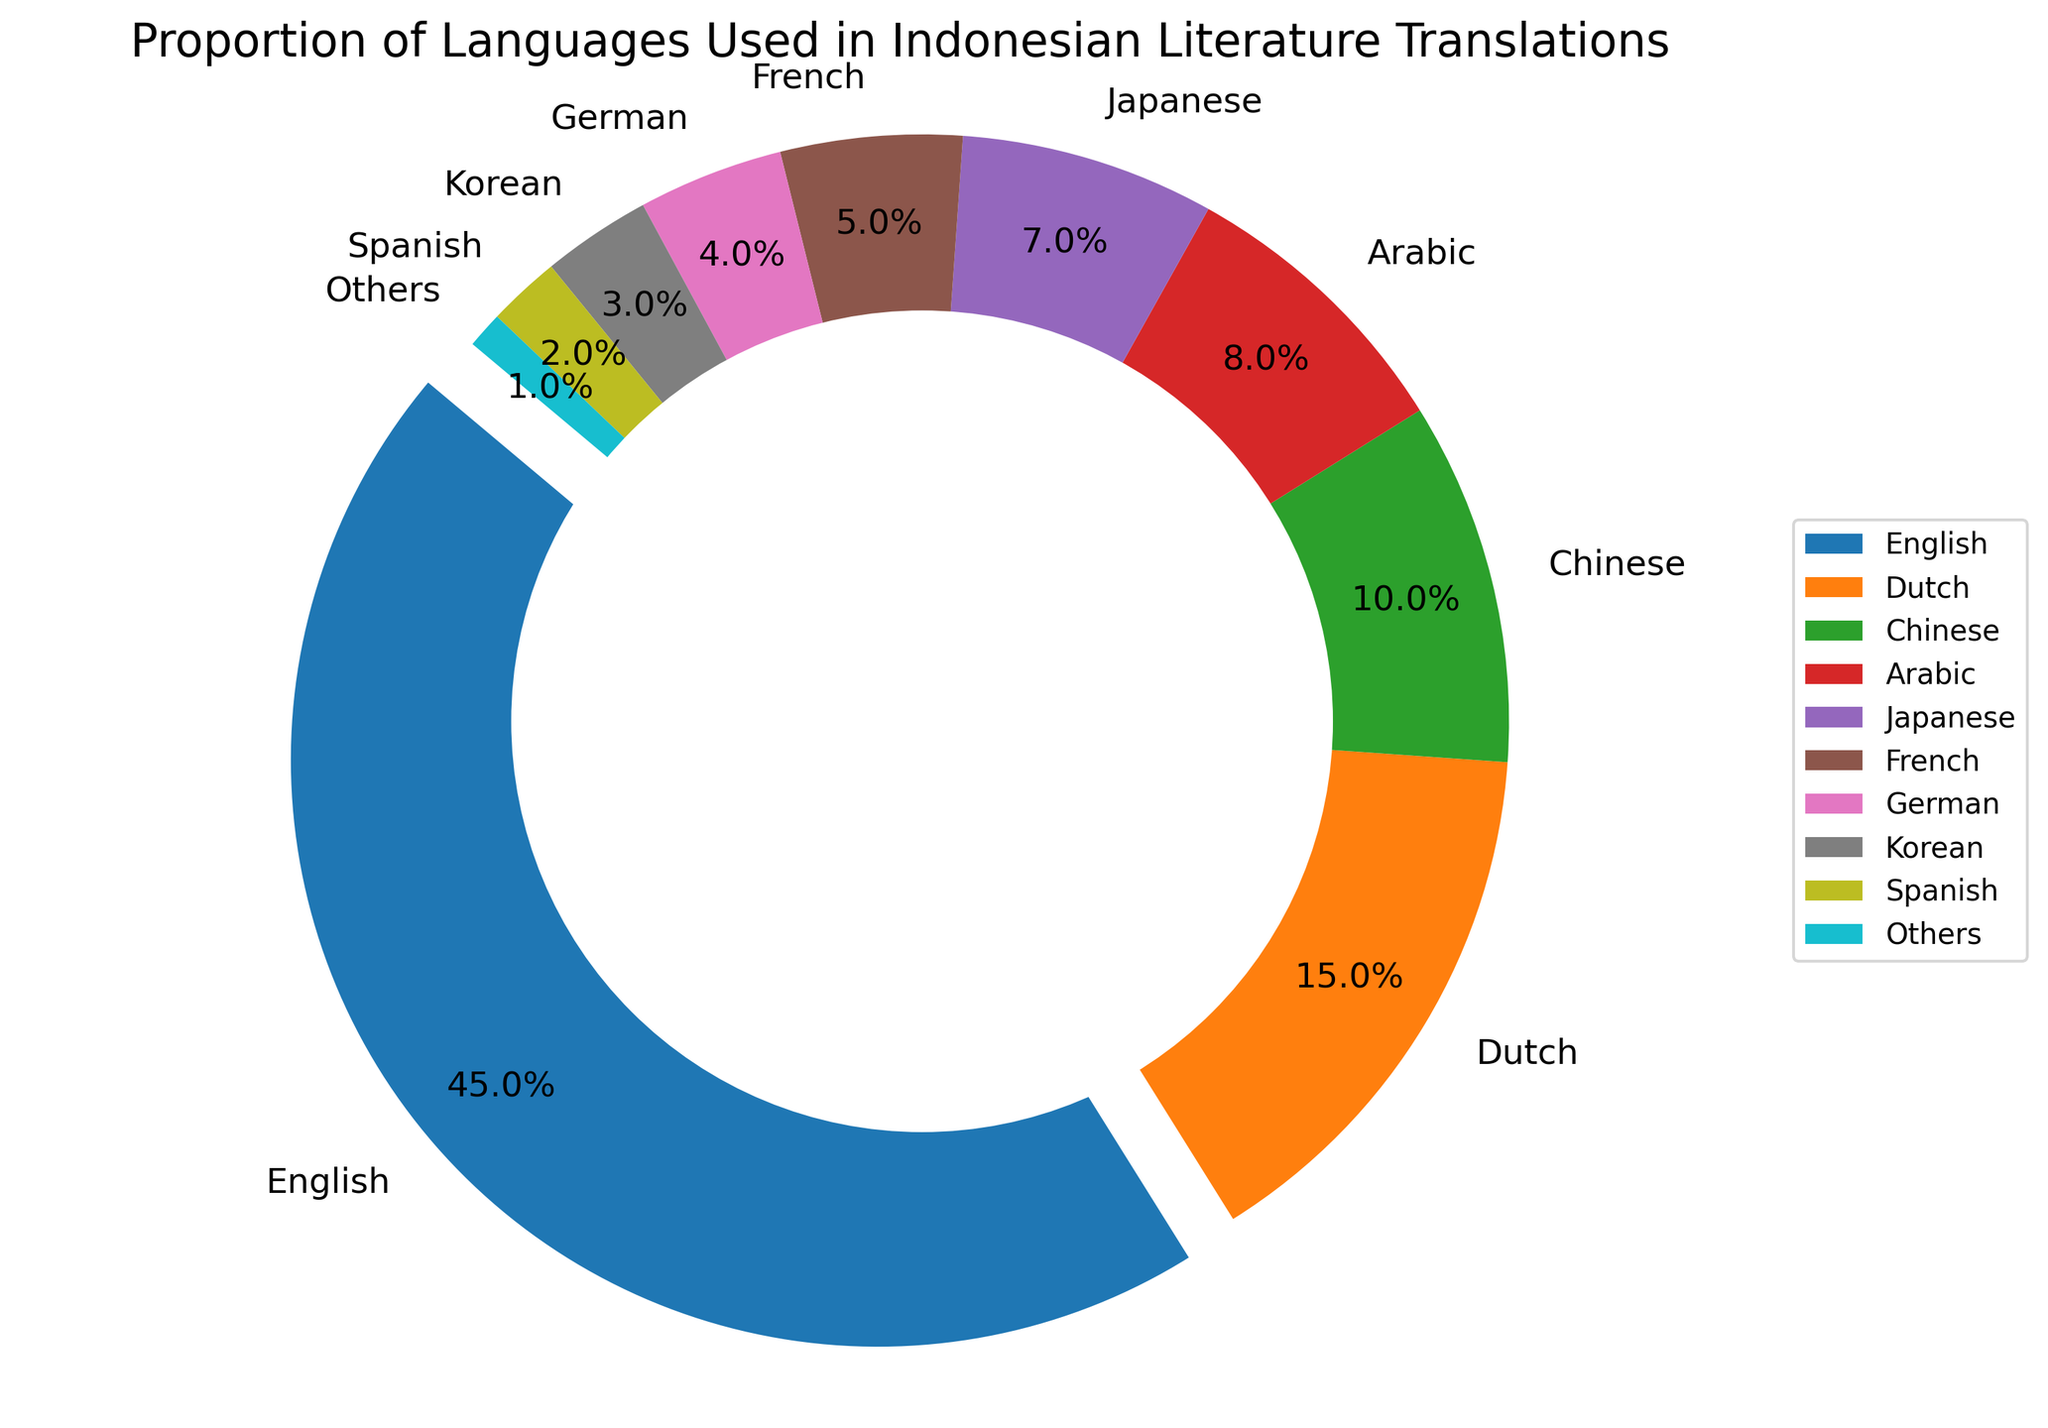Which language has the highest proportion of translations in Indonesian literature? By identifying the segment with the largest proportion and the highlighted slice due to the explode parameter used, we can see that English occupies the largest segment.
Answer: English Which languages together make up more than 50% of the translations? Summing the proportions of languages from highest to lowest until the total surpasses 50%: English (45%) + Dutch (15%) = 60%. Therefore, English and Dutch together exceed 50%.
Answer: English, Dutch What is the difference in proportion between translations from Japanese and French? Locate the respective segments and subtract the smaller percentage from the larger one: 7% (Japanese) - 5% (French) = 2%.
Answer: 2% Is the proportion of Arabic translations greater than Korean translations? Compare the segments for Arabic (8%) and Korean (3%). Since 8% > 3%, Arabic translations outnumber Korean translations.
Answer: Yes What is the total percentage of translations from languages other than Dutch and French? Add the proportions of all segments except Dutch (15%) and French (5%): 45 (English) + 10 (Chinese) + 8 (Arabic) + 7 (Japanese) + 4 (German) + 3 (Korean) + 2 (Spanish) + 1 (Others) = 80%.
Answer: 80% Which language proportion is depicted using an exploded slice? Identifying the segment that is visually highlighted or "exploded" in the pie chart, it can be seen that English is emphasized.
Answer: English What is the combined proportion of translations from Arabic and German? Sum the proportions for Arabic and German segments: 8% (Arabic) + 4% (German) = 12%.
Answer: 12% Which language has a lower proportion of translations, Spanish or Japanese? Comparing the segments for Spanish (2%) and Japanese (7%), Spanish has a lower proportion.
Answer: Spanish What percentage of translations are from Asian languages (Chinese, Japanese, Korean)? Sum the proportions of Asian languages: 10% (Chinese) + 7% (Japanese) + 3% (Korean) = 20%.
Answer: 20% How much higher is the proportion of English translations compared to German translations? Subtract the proportion of German translations from that of English: 45% (English) - 4% (German) = 41%.
Answer: 41% 